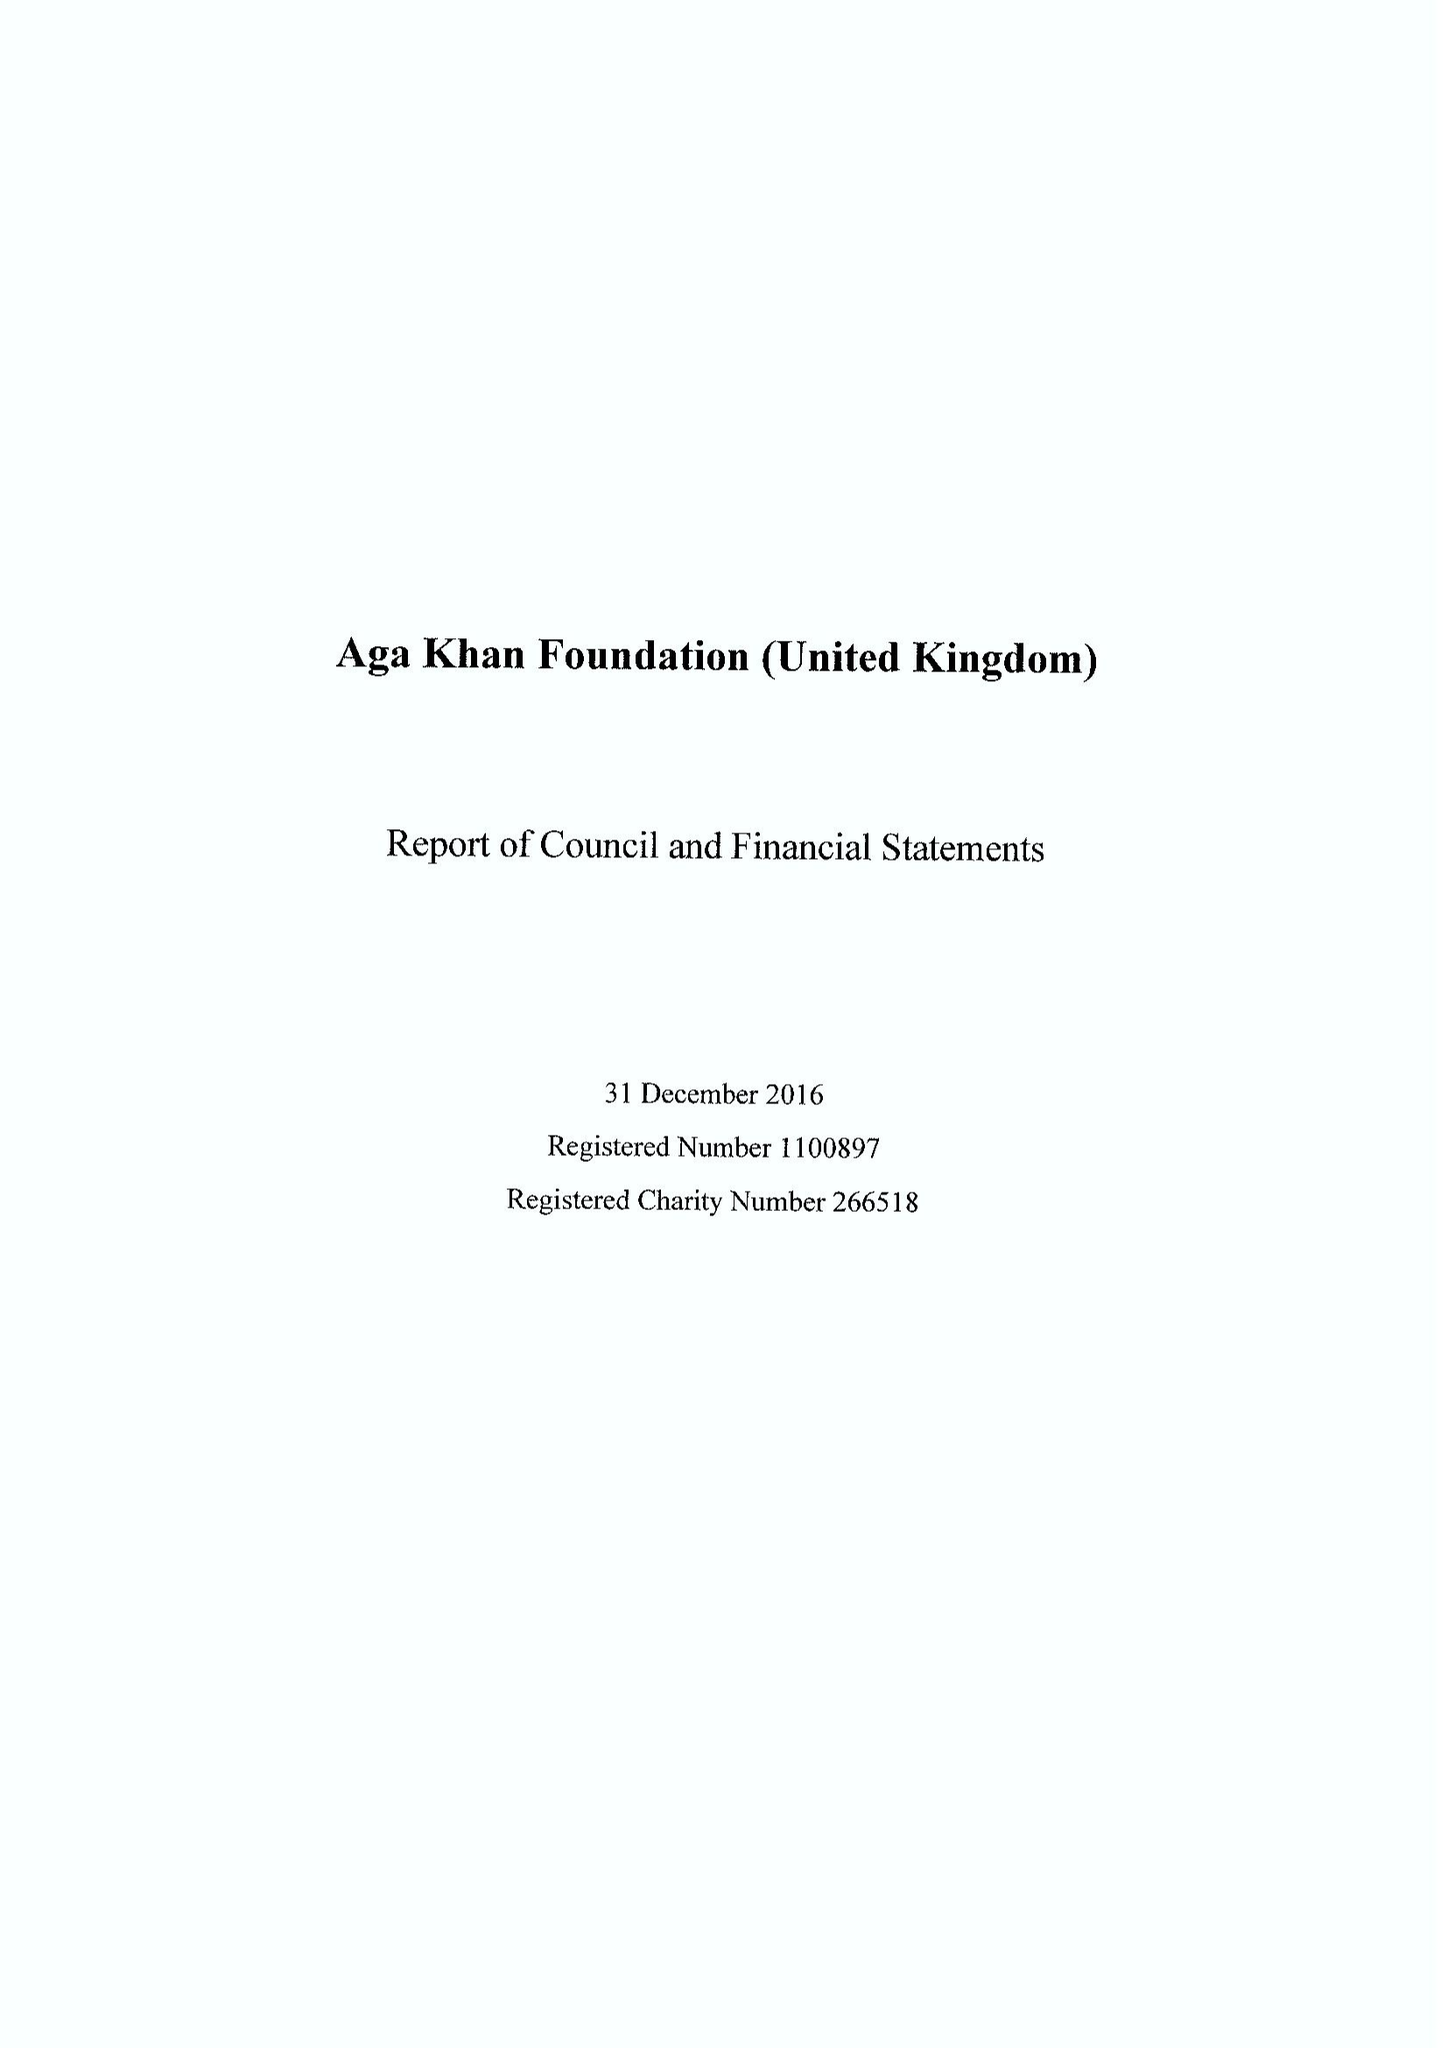What is the value for the spending_annually_in_british_pounds?
Answer the question using a single word or phrase. 25141000.00 